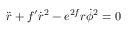Convert formula to latex. <formula><loc_0><loc_0><loc_500><loc_500>\ddot { r } + f ^ { \prime } \dot { r } ^ { 2 } - e ^ { 2 f } r \dot { \phi } ^ { 2 } = 0</formula> 